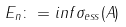<formula> <loc_0><loc_0><loc_500><loc_500>E _ { n } \colon = i n f \sigma _ { e s s } ( A )</formula> 